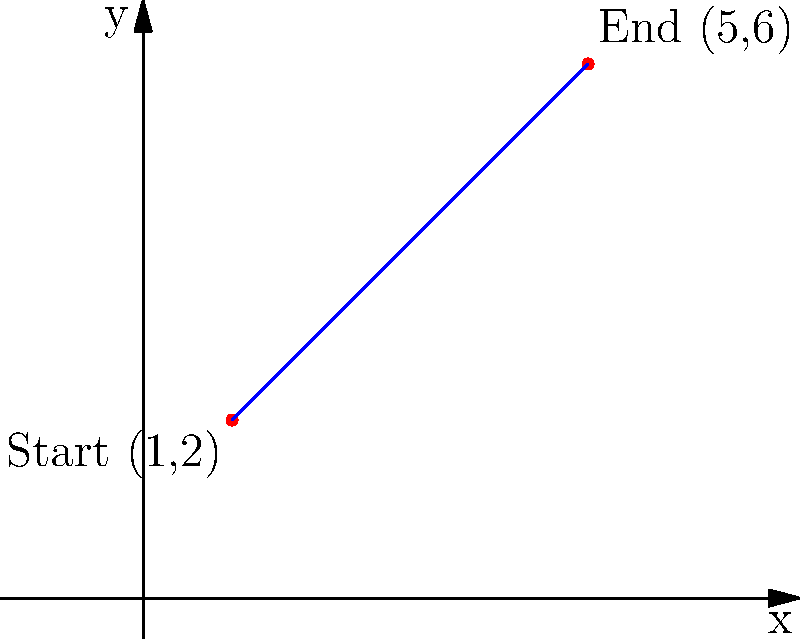During Gazpacho's latest performance, the lead singer moved from position (1,2) to (5,6) on the stage. Calculate the slope of the line connecting these two points. To find the slope of a line connecting two points, we use the slope formula:

$$ m = \frac{y_2 - y_1}{x_2 - x_1} $$

Where $(x_1, y_1)$ is the starting point and $(x_2, y_2)$ is the ending point.

Given:
- Starting point: (1, 2)
- Ending point: (5, 6)

Step 1: Identify the coordinates
$x_1 = 1$, $y_1 = 2$
$x_2 = 5$, $y_2 = 6$

Step 2: Plug the values into the slope formula
$$ m = \frac{6 - 2}{5 - 1} $$

Step 3: Simplify
$$ m = \frac{4}{4} = 1 $$

Therefore, the slope of the line connecting the lead singer's starting and ending positions is 1.
Answer: 1 